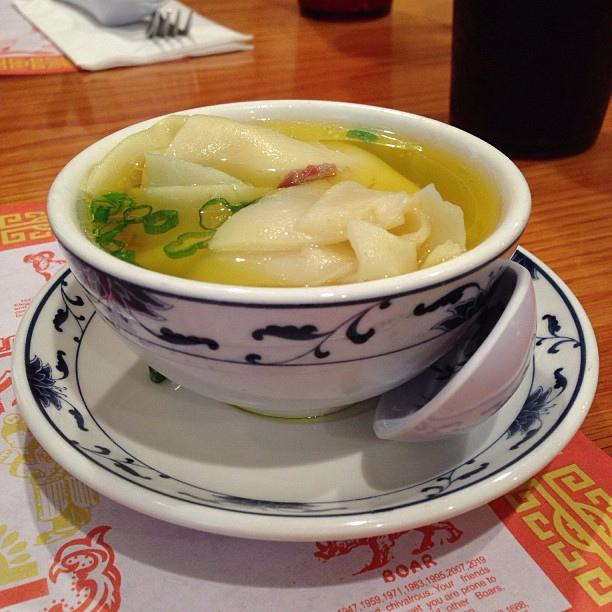What is traditionally eaten as an accompaniment to this dish? noodles 